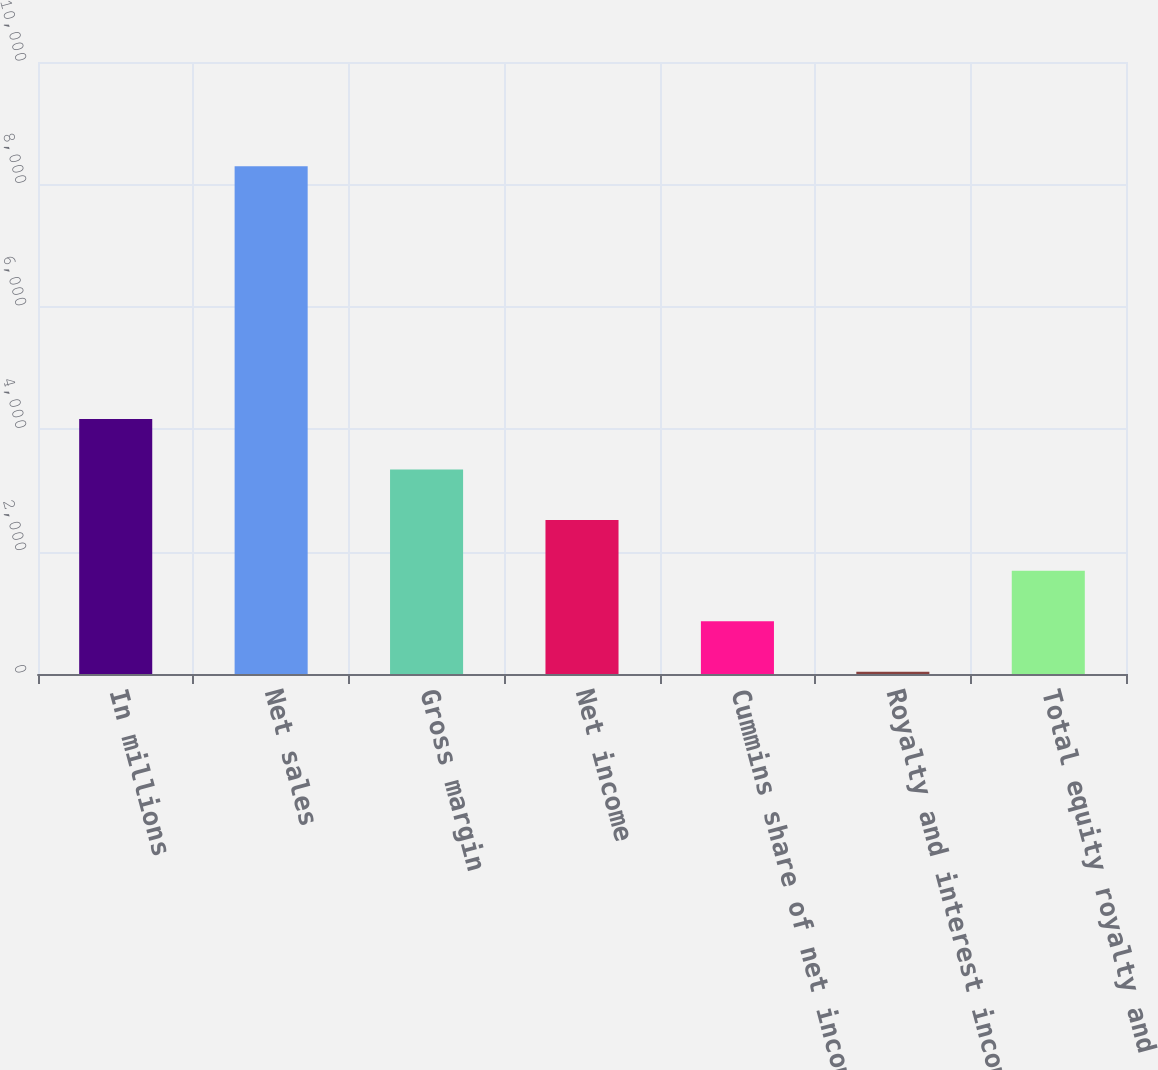<chart> <loc_0><loc_0><loc_500><loc_500><bar_chart><fcel>In millions<fcel>Net sales<fcel>Gross margin<fcel>Net income<fcel>Cummins share of net income<fcel>Royalty and interest income<fcel>Total equity royalty and<nl><fcel>4166.5<fcel>8296<fcel>3340.6<fcel>2514.7<fcel>862.9<fcel>37<fcel>1688.8<nl></chart> 